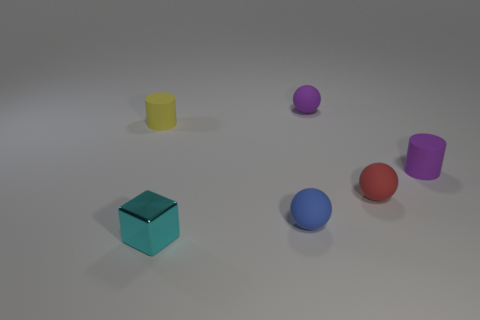What number of other objects are the same material as the tiny blue sphere?
Your answer should be compact. 4. There is a purple rubber thing that is on the left side of the small purple matte cylinder; what size is it?
Provide a succinct answer. Small. The yellow thing that is the same material as the red object is what shape?
Make the answer very short. Cylinder. Are the tiny cube and the tiny red ball behind the small blue sphere made of the same material?
Offer a terse response. No. Do the purple object behind the purple matte cylinder and the tiny red thing have the same shape?
Offer a very short reply. Yes. What is the material of the small blue object that is the same shape as the small red object?
Your answer should be compact. Rubber. Is the shape of the blue rubber thing the same as the matte thing left of the small cyan metallic block?
Offer a very short reply. No. The thing that is both in front of the red rubber thing and right of the metal object is what color?
Your answer should be very brief. Blue. Are there any large blue metallic objects?
Ensure brevity in your answer.  No. Are there the same number of purple spheres in front of the red object and small yellow metallic things?
Provide a succinct answer. Yes. 